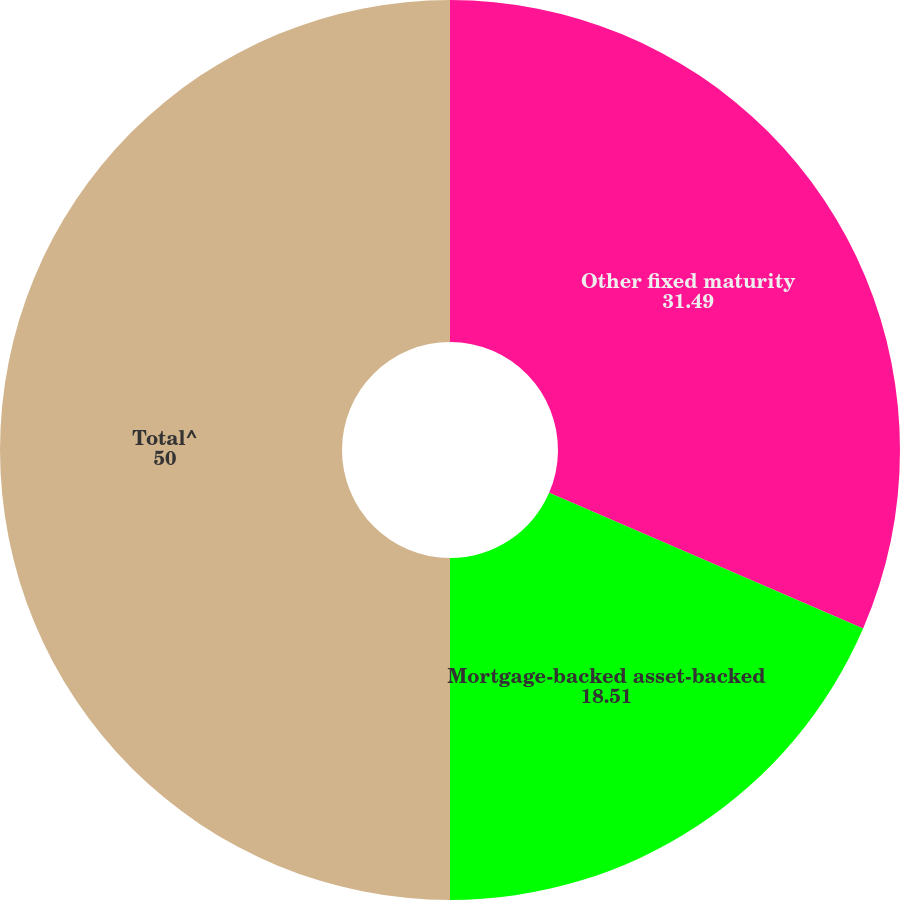<chart> <loc_0><loc_0><loc_500><loc_500><pie_chart><fcel>Other fixed maturity<fcel>Mortgage-backed asset-backed<fcel>Total^<nl><fcel>31.49%<fcel>18.51%<fcel>50.0%<nl></chart> 